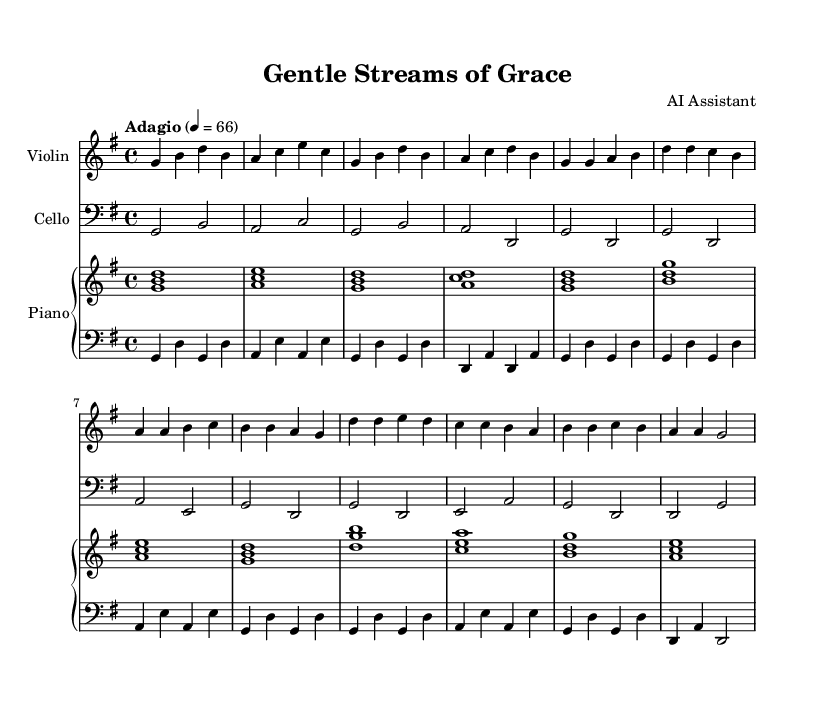What is the key signature of this music? The key signature is G major, which has one sharp (F#). It can be identified by looking at the key signature at the beginning of the score, where one sharp is indicated.
Answer: G major What is the time signature of this piece? The time signature is 4/4, which means there are four beats in each measure and a quarter note gets one beat. This is displayed at the beginning of the score next to the key signature.
Answer: 4/4 What is the tempo marking of this music? The tempo marking is "Adagio," which indicates a slow tempo. This can be found in the tempo instruction located at the beginning of the score.
Answer: Adagio How many measures are in the chorus section? The chorus section consists of four measures. By counting the vertical lines separating the group of notes in the chorus part of the score, four distinct measures can be identified.
Answer: 4 What is the highest note played by the violin? The highest note played by the violin is D. By reviewing the notes in the violin part, D is the highest note reached during the chorus section.
Answer: D What is the harmony structure of the introduction? The harmony structure of the introduction follows a G major chord progression: G, A minor, G, A major. This is identifiable by looking at the chords used in the upper piano staff during the introduction measures.
Answer: G major Which instruments are featured in this piece? The instruments featured in this piece are the violin, cello, and piano. This can be determined from the score, which explicitly lists these instruments at the beginning and contains parts written for each.
Answer: Violin, Cello, Piano 